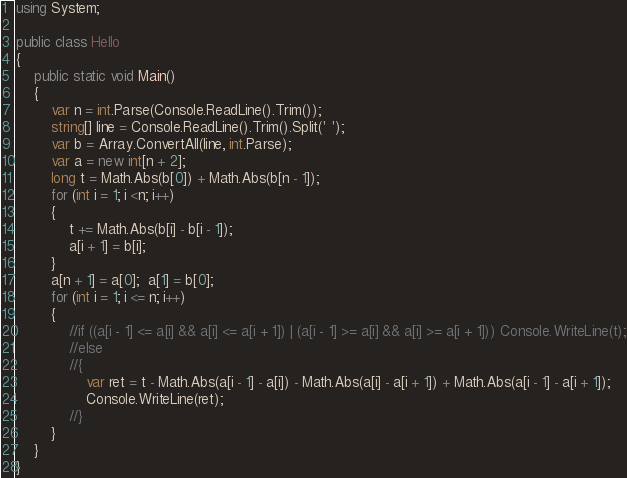<code> <loc_0><loc_0><loc_500><loc_500><_C#_>using System;

public class Hello
{
    public static void Main()
    {
        var n = int.Parse(Console.ReadLine().Trim());
        string[] line = Console.ReadLine().Trim().Split(' ');
        var b = Array.ConvertAll(line, int.Parse);
        var a = new int[n + 2];
        long t = Math.Abs(b[0]) + Math.Abs(b[n - 1]);
        for (int i = 1; i <n; i++)
        {
            t += Math.Abs(b[i] - b[i - 1]);
            a[i + 1] = b[i];
        }
        a[n + 1] = a[0];  a[1] = b[0];
        for (int i = 1; i <= n; i++)
        {
            //if ((a[i - 1] <= a[i] && a[i] <= a[i + 1]) | (a[i - 1] >= a[i] && a[i] >= a[i + 1])) Console.WriteLine(t);
            //else
            //{
                var ret = t - Math.Abs(a[i - 1] - a[i]) - Math.Abs(a[i] - a[i + 1]) + Math.Abs(a[i - 1] - a[i + 1]);
                Console.WriteLine(ret);
            //}
        }
    }
}
</code> 